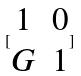<formula> <loc_0><loc_0><loc_500><loc_500>[ \begin{matrix} 1 & 0 \\ G & 1 \end{matrix} ]</formula> 